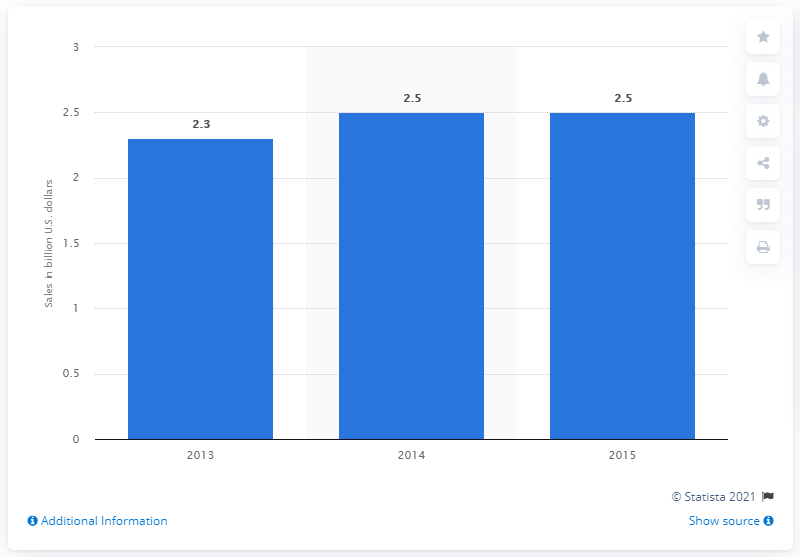Specify some key components in this picture. In 2015, the online sales of The Gap Inc. were 2.5 billion dollars. The online sales of The Gap Inc. in 2013 were approximately 2.3 billion dollars. 